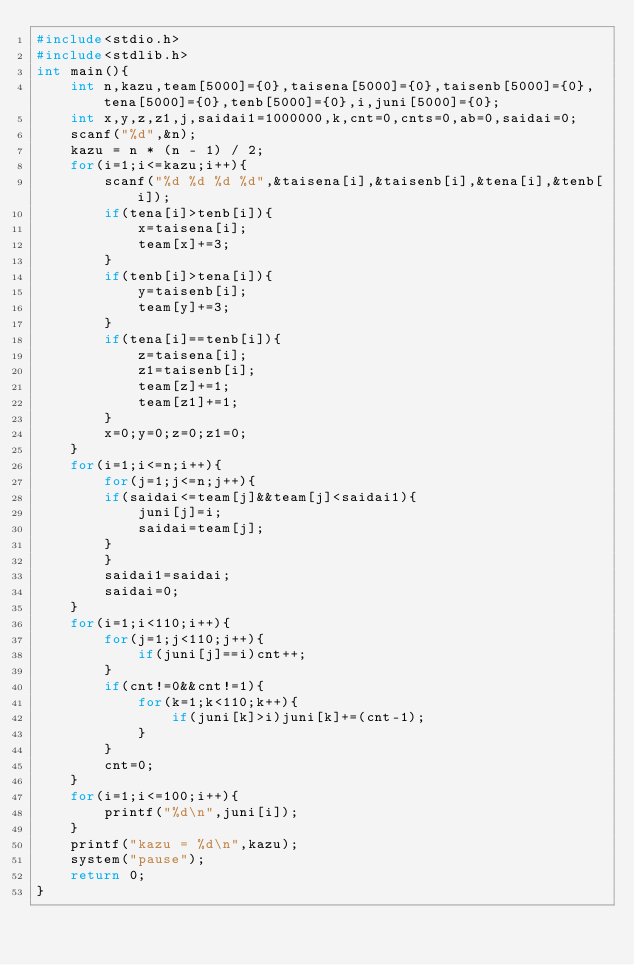Convert code to text. <code><loc_0><loc_0><loc_500><loc_500><_C_>#include<stdio.h>
#include<stdlib.h>
int main(){
    int n,kazu,team[5000]={0},taisena[5000]={0},taisenb[5000]={0},tena[5000]={0},tenb[5000]={0},i,juni[5000]={0};
    int x,y,z,z1,j,saidai1=1000000,k,cnt=0,cnts=0,ab=0,saidai=0;
    scanf("%d",&n);
    kazu = n * (n - 1) / 2;
    for(i=1;i<=kazu;i++){
        scanf("%d %d %d %d",&taisena[i],&taisenb[i],&tena[i],&tenb[i]);
        if(tena[i]>tenb[i]){
            x=taisena[i];
            team[x]+=3;
        }
        if(tenb[i]>tena[i]){
            y=taisenb[i];
            team[y]+=3;
        }
        if(tena[i]==tenb[i]){
            z=taisena[i];
            z1=taisenb[i];
            team[z]+=1;
            team[z1]+=1;
        }
        x=0;y=0;z=0;z1=0;
    }
    for(i=1;i<=n;i++){
        for(j=1;j<=n;j++){
        if(saidai<=team[j]&&team[j]<saidai1){
            juni[j]=i;
            saidai=team[j];
        }
        }
        saidai1=saidai;
        saidai=0;
    }
    for(i=1;i<110;i++){
        for(j=1;j<110;j++){
            if(juni[j]==i)cnt++;
        }
        if(cnt!=0&&cnt!=1){
            for(k=1;k<110;k++){
                if(juni[k]>i)juni[k]+=(cnt-1);
            }
        }
        cnt=0;
    }
    for(i=1;i<=100;i++){
        printf("%d\n",juni[i]);
    }
    printf("kazu = %d\n",kazu);
    system("pause");
    return 0;
}</code> 